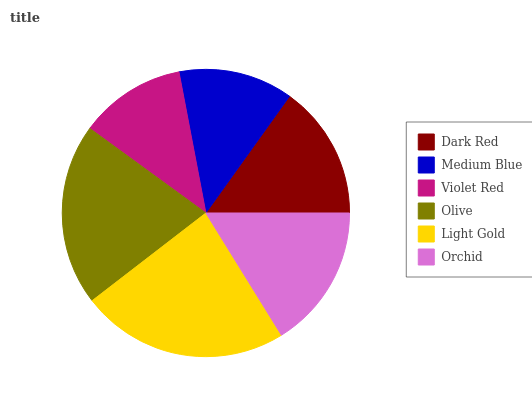Is Violet Red the minimum?
Answer yes or no. Yes. Is Light Gold the maximum?
Answer yes or no. Yes. Is Medium Blue the minimum?
Answer yes or no. No. Is Medium Blue the maximum?
Answer yes or no. No. Is Dark Red greater than Medium Blue?
Answer yes or no. Yes. Is Medium Blue less than Dark Red?
Answer yes or no. Yes. Is Medium Blue greater than Dark Red?
Answer yes or no. No. Is Dark Red less than Medium Blue?
Answer yes or no. No. Is Orchid the high median?
Answer yes or no. Yes. Is Dark Red the low median?
Answer yes or no. Yes. Is Dark Red the high median?
Answer yes or no. No. Is Medium Blue the low median?
Answer yes or no. No. 